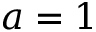Convert formula to latex. <formula><loc_0><loc_0><loc_500><loc_500>a = 1</formula> 